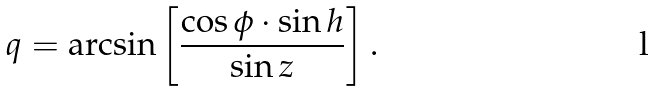<formula> <loc_0><loc_0><loc_500><loc_500>q = \arcsin \left [ \frac { \cos \phi \cdot \sin h } { \sin z } \right ] .</formula> 